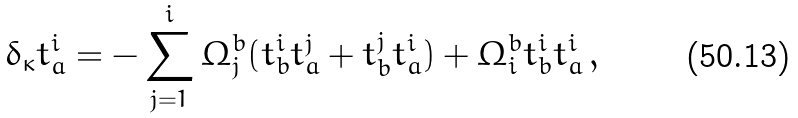Convert formula to latex. <formula><loc_0><loc_0><loc_500><loc_500>\delta _ { \kappa } t _ { a } ^ { i } = - \sum _ { j = 1 } ^ { i } \Omega _ { j } ^ { b } ( t _ { b } ^ { i } t _ { a } ^ { j } + t _ { b } ^ { j } t _ { a } ^ { i } ) + \Omega _ { i } ^ { b } t _ { b } ^ { i } t _ { a } ^ { i } \, ,</formula> 